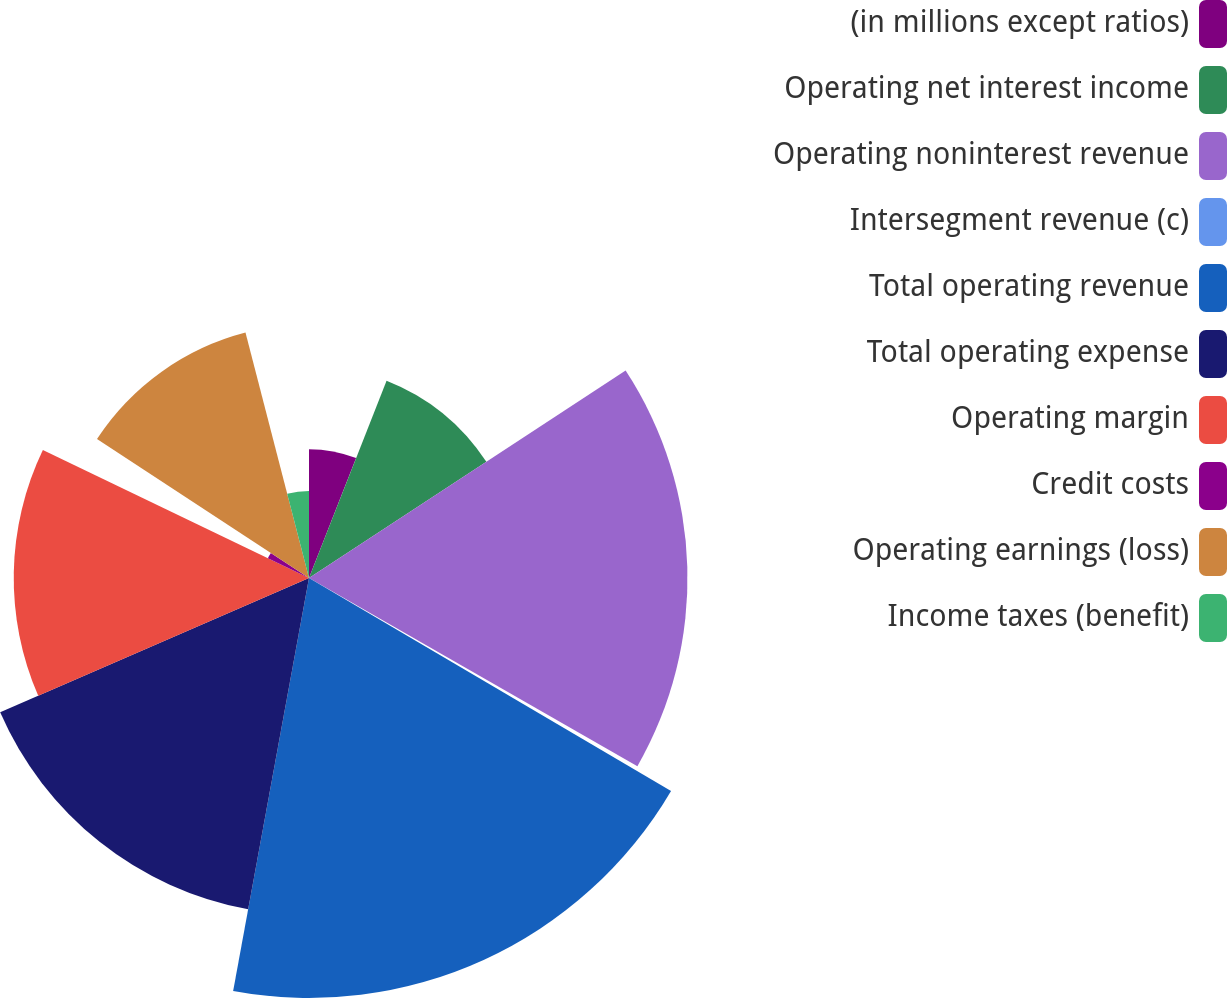<chart> <loc_0><loc_0><loc_500><loc_500><pie_chart><fcel>(in millions except ratios)<fcel>Operating net interest income<fcel>Operating noninterest revenue<fcel>Intersegment revenue (c)<fcel>Total operating revenue<fcel>Total operating expense<fcel>Operating margin<fcel>Credit costs<fcel>Operating earnings (loss)<fcel>Income taxes (benefit)<nl><fcel>5.96%<fcel>9.81%<fcel>17.51%<fcel>0.18%<fcel>19.43%<fcel>15.58%<fcel>13.66%<fcel>2.11%<fcel>11.73%<fcel>4.03%<nl></chart> 